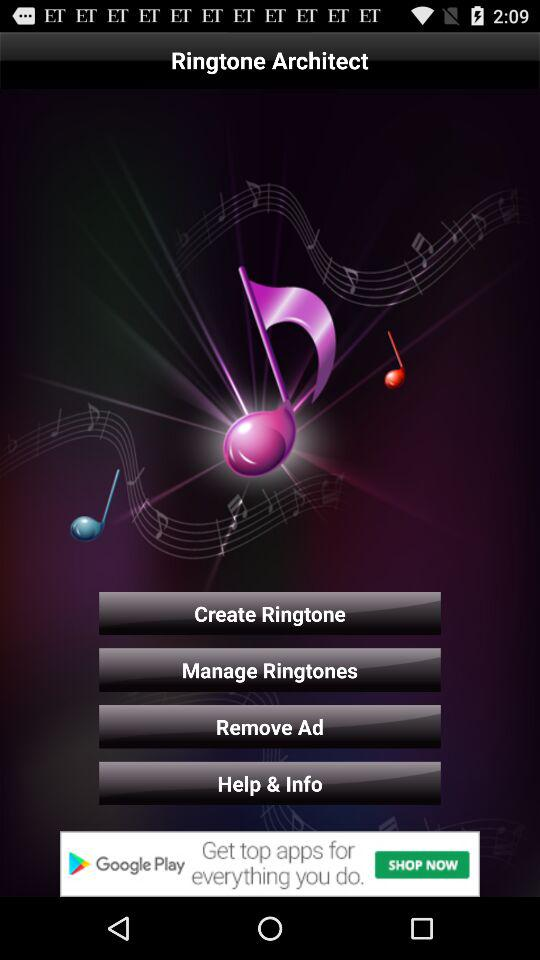What is the name of the application? The name of the application is "Ringtone Architect". 